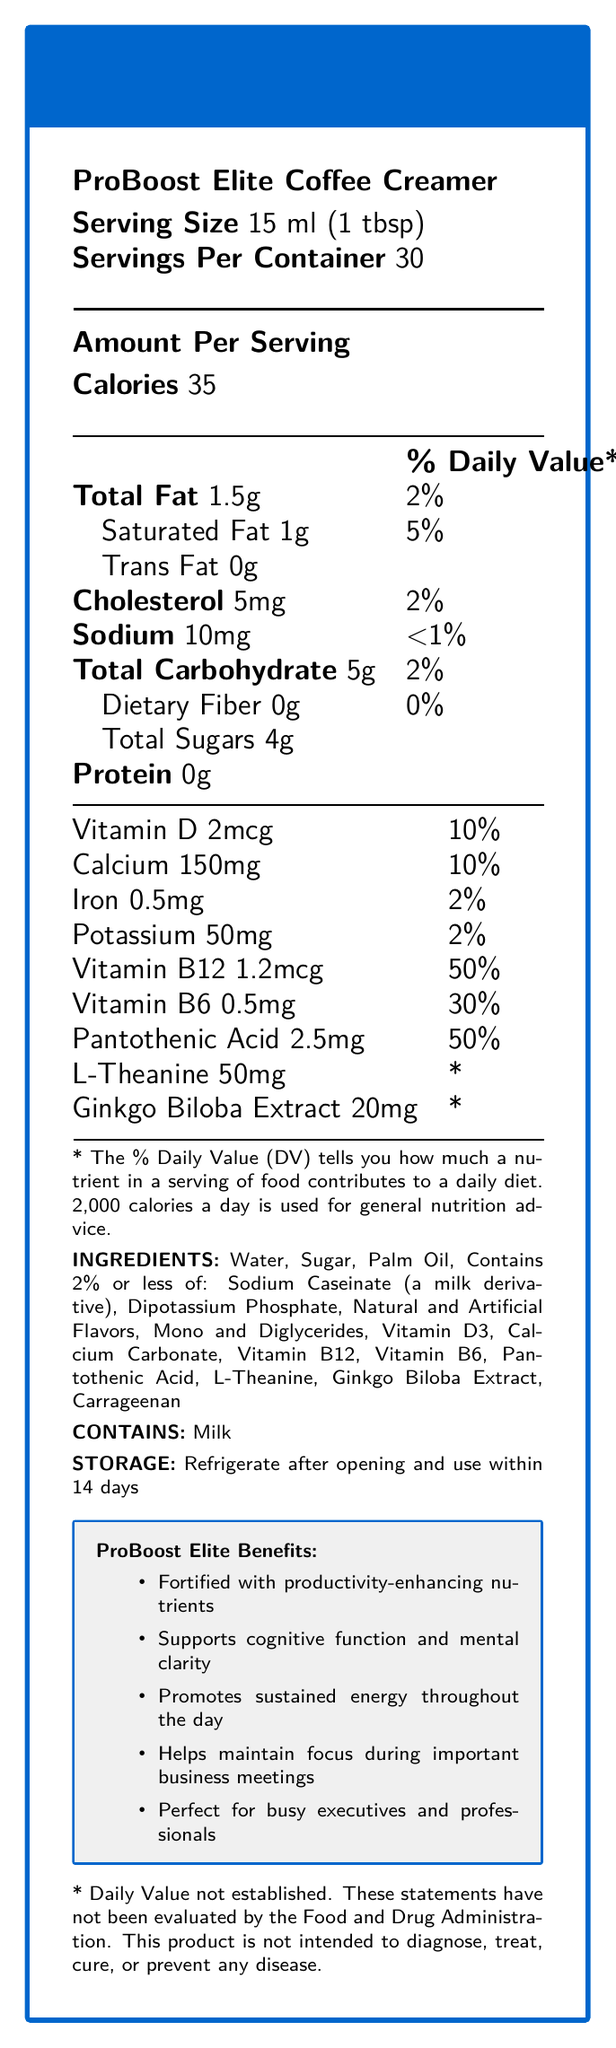What is the serving size of ProBoost Elite Coffee Creamer? The serving size is clearly mentioned as "15 ml (1 tbsp)" in the document.
Answer: 15 ml (1 tbsp) How many servings are there per container of ProBoost Elite Coffee Creamer? The document specifies that there are 30 servings per container.
Answer: 30 How much Vitamin B12 does one serving of the coffee creamer contain? The document indicates that one serving contains 1.2mcg of Vitamin B12.
Answer: 1.2mcg What is the percentage of Daily Value for Vitamin D in one serving? The document shows that one serving provides 10% of the Daily Value for Vitamin D.
Answer: 10% How many calories are there in one serving of ProBoost Elite Coffee Creamer? The document states that there are 35 calories per serving.
Answer: 35 How much Pantothenic Acid is in one serving? The document lists 2.5mg of Pantothenic Acid per serving.
Answer: 2.5mg Which nutrient provides the highest percentage of Daily Value in this coffee creamer? A. Vitamin D B. Calcium C. Vitamin B12 D. Iron The document shows Vitamin B12 provides 50% of the Daily Value, the highest among the listed nutrients.
Answer: C. Vitamin B12 What is the total amount of carbohydrates in one serving? A. 1g B. 2g C. 5g D. 7g The document mentions that there are 5g of total carbohydrates per serving.
Answer: C. 5g Does the creamer contain any trans fat? The document specifically mentions that there is 0g of trans fat in one serving.
Answer: No Is the ProBoost Elite Coffee Creamer suitable for people with milk allergies? The document indicates that the product contains milk and explicitly mentions "Contains Milk."
Answer: No Summarize the main claims and nutritional highlights of ProBoost Elite Coffee Creamer. The creamer is fortified with nutrients proven to aid productivity and mental function, including significant amounts of Vitamin B12 and B6. The packaging claims include support for cognitive function, energy, and mental clarity, ideal for busy executives. The nutrient information also highlights the absence of trans fat and the presence of other beneficial components like L-Theanine and Ginkgo Biloba Extract.
Answer: ProBoost Elite Coffee Creamer is a vitamin-fortified creamer designed to enhance productivity with nutrients like Vitamin B12, B6, and Pantothenic Acid. It supports cognitive function, mental clarity, sustained energy, and focus, making it ideal for busy professionals. Can the exact impact of L-Theanine and Ginkgo Biloba Extract be determined from the provided daily values? The document states that daily values for L-Theanine and Ginkgo Biloba Extract have not been established, so their exact impact cannot be determined from this information.
Answer: Not enough information How much sodium does one serving of the coffee creamer contain? The document states that one serving contains 10mg of sodium.
Answer: 10mg Does the product help maintain focus during important business meetings? One of the marketing claims listed in the document is "Helps maintain focus during important business meetings."
Answer: Yes What is the percentage of Daily Value for iron in one serving of the coffee creamer? The document indicates that one serving provides 2% of the Daily Value for iron.
Answer: 2% 